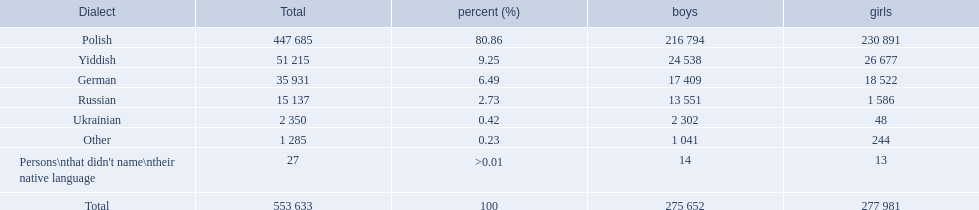Which language options are listed? Polish, Yiddish, German, Russian, Ukrainian, Other, Persons\nthat didn't name\ntheir native language. Of these, which did .42% of the people select? Ukrainian. 